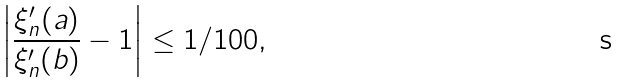Convert formula to latex. <formula><loc_0><loc_0><loc_500><loc_500>\left | \frac { \xi _ { n } ^ { \prime } ( a ) } { \xi _ { n } ^ { \prime } ( b ) } - 1 \right | \leq 1 / 1 0 0 ,</formula> 